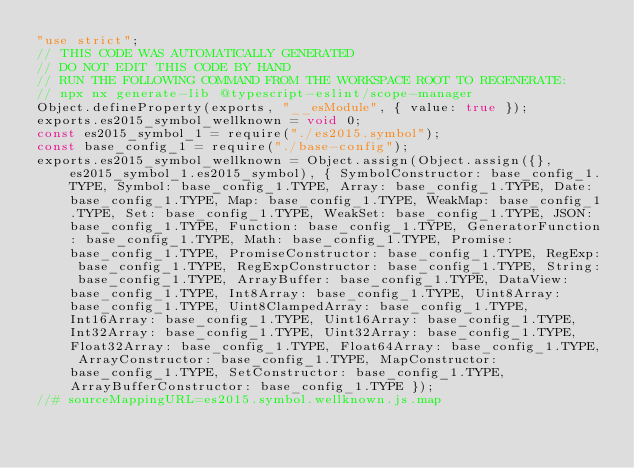Convert code to text. <code><loc_0><loc_0><loc_500><loc_500><_JavaScript_>"use strict";
// THIS CODE WAS AUTOMATICALLY GENERATED
// DO NOT EDIT THIS CODE BY HAND
// RUN THE FOLLOWING COMMAND FROM THE WORKSPACE ROOT TO REGENERATE:
// npx nx generate-lib @typescript-eslint/scope-manager
Object.defineProperty(exports, "__esModule", { value: true });
exports.es2015_symbol_wellknown = void 0;
const es2015_symbol_1 = require("./es2015.symbol");
const base_config_1 = require("./base-config");
exports.es2015_symbol_wellknown = Object.assign(Object.assign({}, es2015_symbol_1.es2015_symbol), { SymbolConstructor: base_config_1.TYPE, Symbol: base_config_1.TYPE, Array: base_config_1.TYPE, Date: base_config_1.TYPE, Map: base_config_1.TYPE, WeakMap: base_config_1.TYPE, Set: base_config_1.TYPE, WeakSet: base_config_1.TYPE, JSON: base_config_1.TYPE, Function: base_config_1.TYPE, GeneratorFunction: base_config_1.TYPE, Math: base_config_1.TYPE, Promise: base_config_1.TYPE, PromiseConstructor: base_config_1.TYPE, RegExp: base_config_1.TYPE, RegExpConstructor: base_config_1.TYPE, String: base_config_1.TYPE, ArrayBuffer: base_config_1.TYPE, DataView: base_config_1.TYPE, Int8Array: base_config_1.TYPE, Uint8Array: base_config_1.TYPE, Uint8ClampedArray: base_config_1.TYPE, Int16Array: base_config_1.TYPE, Uint16Array: base_config_1.TYPE, Int32Array: base_config_1.TYPE, Uint32Array: base_config_1.TYPE, Float32Array: base_config_1.TYPE, Float64Array: base_config_1.TYPE, ArrayConstructor: base_config_1.TYPE, MapConstructor: base_config_1.TYPE, SetConstructor: base_config_1.TYPE, ArrayBufferConstructor: base_config_1.TYPE });
//# sourceMappingURL=es2015.symbol.wellknown.js.map</code> 